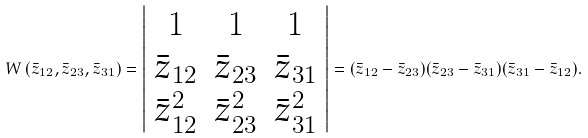Convert formula to latex. <formula><loc_0><loc_0><loc_500><loc_500>W \left ( \bar { z } _ { 1 2 } , \bar { z } _ { 2 3 } , \bar { z } _ { 3 1 } \right ) = \left | \begin{array} { c c c } 1 & 1 & 1 \\ \bar { z } _ { 1 2 } & \bar { z } _ { 2 3 } & \bar { z } _ { 3 1 } \\ { \bar { z } _ { 1 2 } } ^ { 2 } & { \bar { z } _ { 2 3 } } ^ { 2 } & { \bar { z } _ { 3 1 } } ^ { 2 } \end{array} \right | = ( \bar { z } _ { 1 2 } - \bar { z } _ { 2 3 } ) ( \bar { z } _ { 2 3 } - \bar { z } _ { 3 1 } ) ( \bar { z } _ { 3 1 } - \bar { z } _ { 1 2 } ) .</formula> 